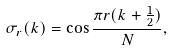<formula> <loc_0><loc_0><loc_500><loc_500>\sigma _ { r } ( k ) = \cos \frac { \pi r ( k + \frac { 1 } { 2 } ) } N ,</formula> 